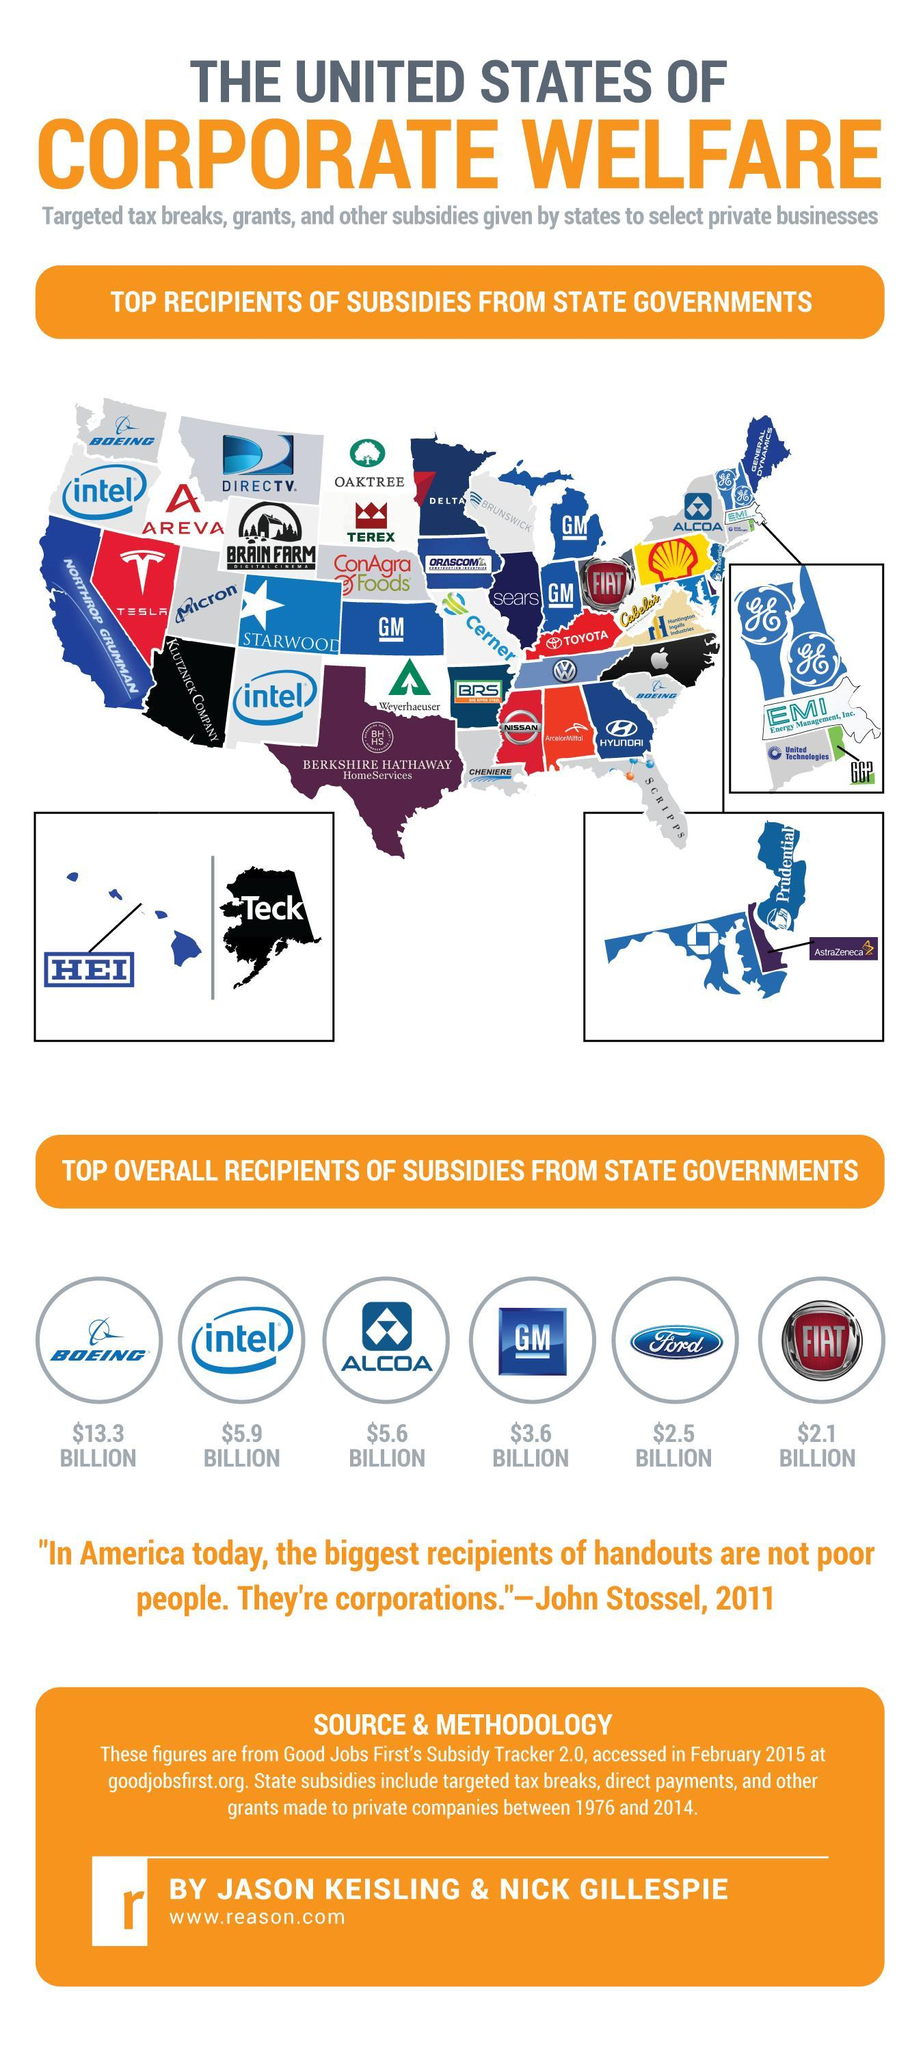Which corporation has received the highest subsidy?
Answer the question with a short phrase. $13.3 BILLION How many top businesses have received subsidies from state governments? 6 